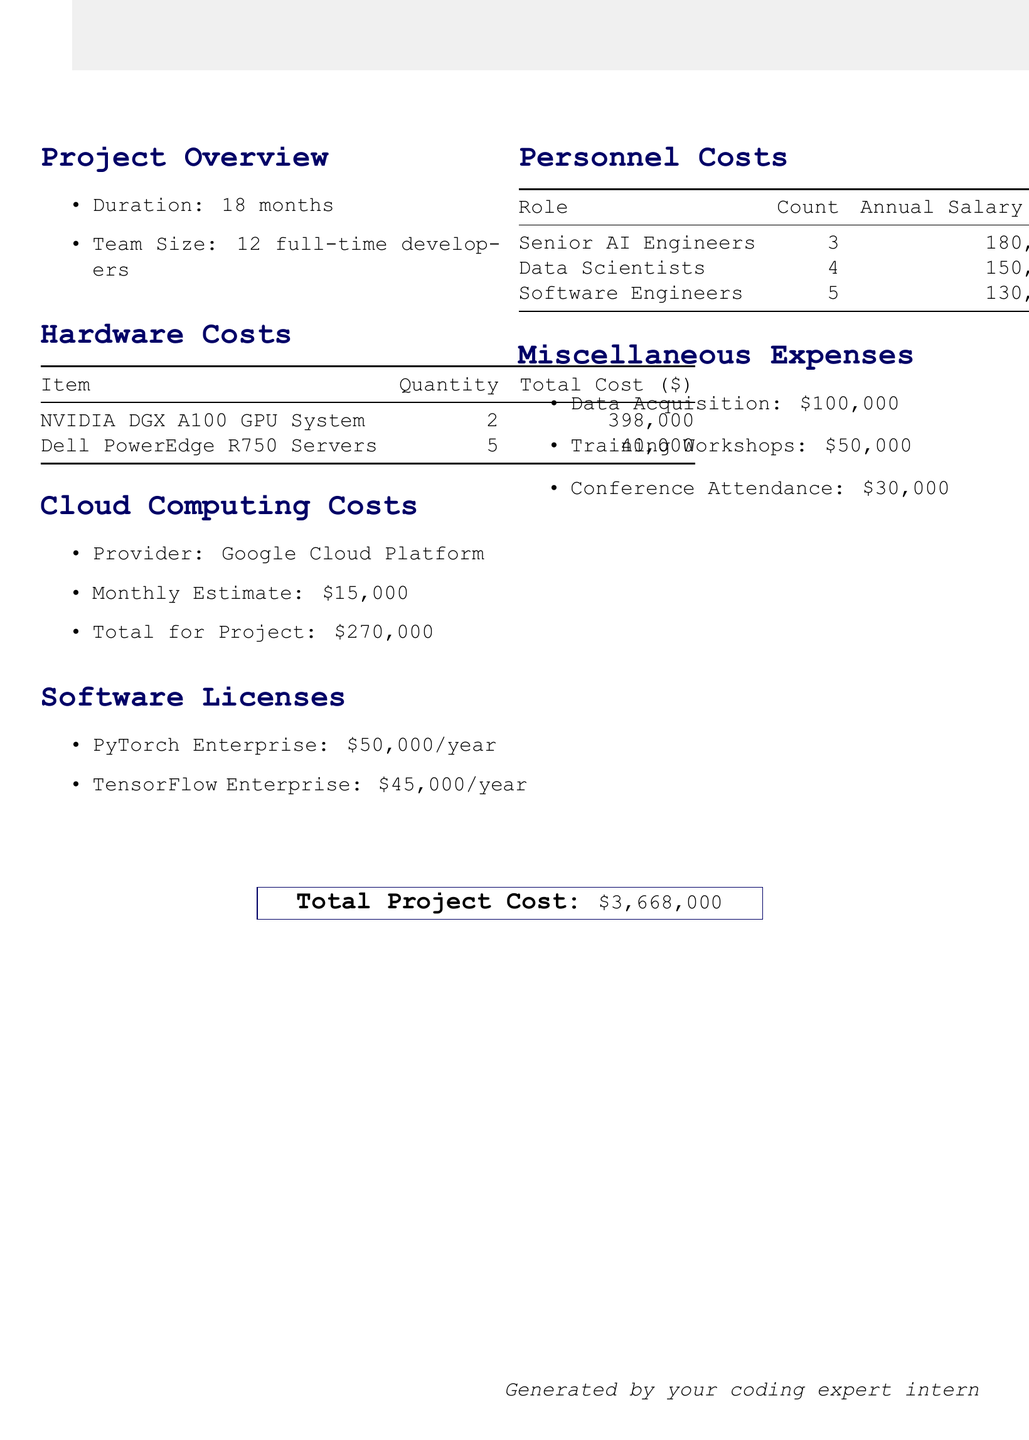What is the project name? The project name is stated in the document as the title of the financial report.
Answer: DeepMind AI Assistant How many servers were purchased? The document lists the quantity of Dell PowerEdge R750 Servers under hardware costs.
Answer: 5 What is the monthly estimate for cloud computing? The monthly estimate for cloud computing is provided in the cloud computing costs section.
Answer: 15000 What is the annual cost of PyTorch Enterprise? The annual cost for the software license of PyTorch Enterprise is clearly mentioned in the software licenses section.
Answer: 50000 What is the total cost for senior AI engineers? The total cost for senior AI engineers is calculated based on their annual salary and count, mentioned in the personnel costs section.
Answer: 810000 Calculate the total personnel cost. The total personnel cost requires adding up the costs of all roles listed in the personnel costs section.
Answer: 2685000 What are the miscellaneous expenses related to training workshops? The document explicitly lists training workshops under miscellaneous expenses with its associated cost.
Answer: 50000 What is the total project cost? The total project cost is stated at the end of the document.
Answer: 3668000 Who generated this financial report? The document credits the author at the bottom of the report.
Answer: your coding expert intern 